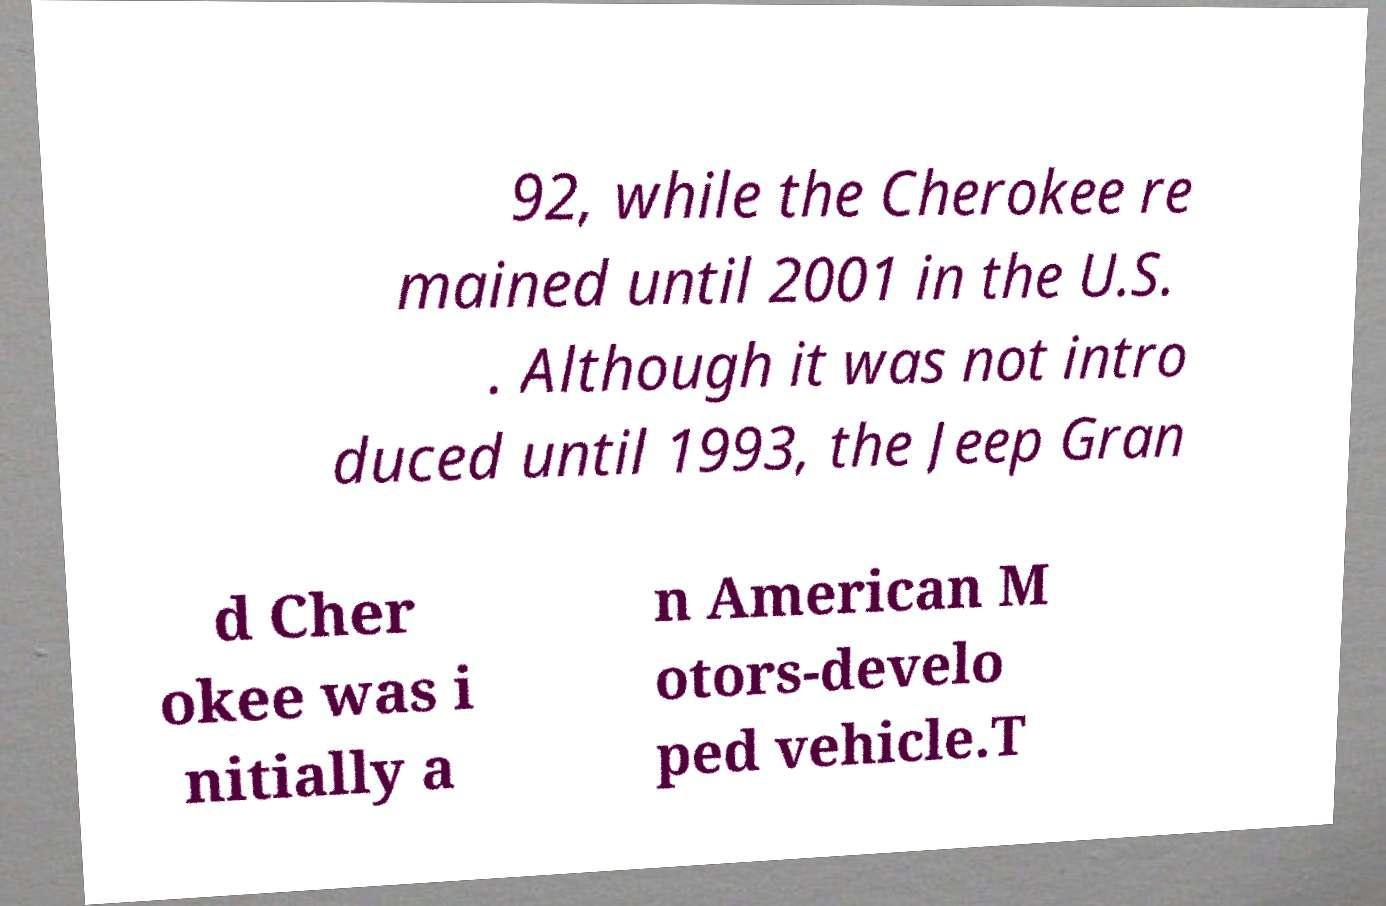What messages or text are displayed in this image? I need them in a readable, typed format. 92, while the Cherokee re mained until 2001 in the U.S. . Although it was not intro duced until 1993, the Jeep Gran d Cher okee was i nitially a n American M otors-develo ped vehicle.T 